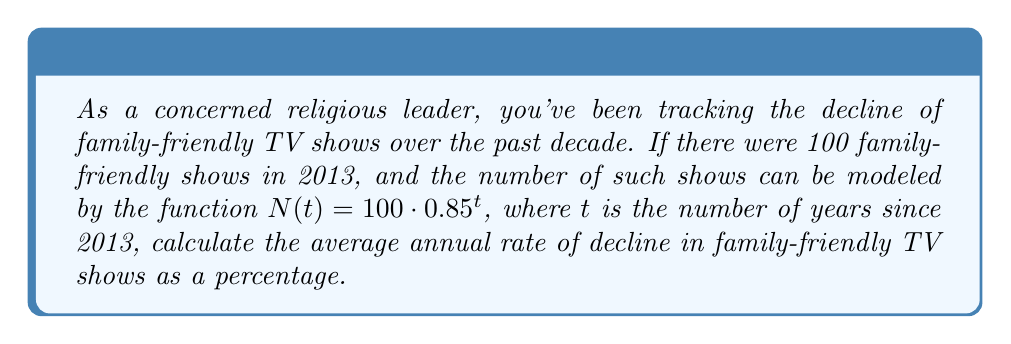Can you answer this question? To solve this problem, we'll use the properties of logarithms and exponential functions:

1) The given function is $N(t) = 100 \cdot 0.85^t$

2) To find the average annual rate of decline, we need to determine the value of $r$ in the equation $0.85 = 1 - r$, where $r$ represents the rate of decline.

3) Rearranging the equation:
   $r = 1 - 0.85 = 0.15$

4) To express this as a percentage, we multiply by 100:
   $0.15 \cdot 100 = 15\%$

5) We can verify this using the logarithmic property of exponential decay:
   $\text{rate} = (1 - b) \cdot 100\%$, where $b$ is the base of the exponential function.

   In this case, $b = 0.85$, so:
   $\text{rate} = (1 - 0.85) \cdot 100\% = 0.15 \cdot 100\% = 15\%$

Therefore, the average annual rate of decline in family-friendly TV shows is 15%.
Answer: 15% 